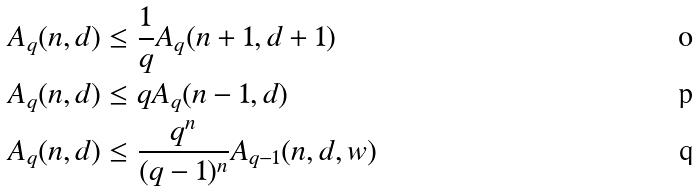<formula> <loc_0><loc_0><loc_500><loc_500>A _ { q } ( n , d ) & \leq \frac { 1 } { q } A _ { q } ( n + 1 , d + 1 ) \\ A _ { q } ( n , d ) & \leq q A _ { q } ( n - 1 , d ) \\ A _ { q } ( n , d ) & \leq \frac { q ^ { n } } { ( q - 1 ) ^ { n } } A _ { q - 1 } ( n , d , w )</formula> 